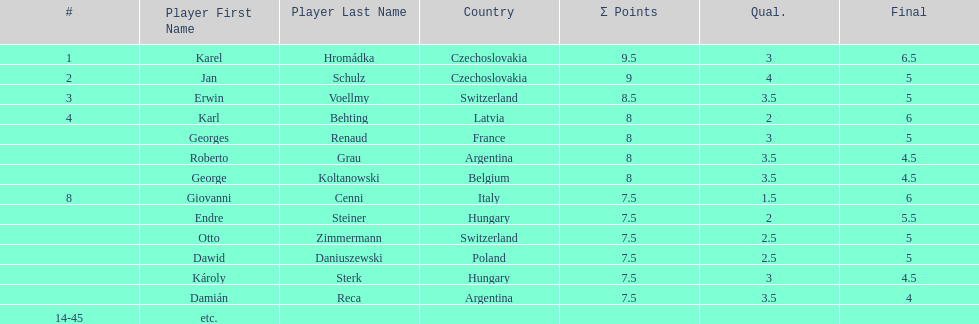How many players tied for 4th place? 4. 